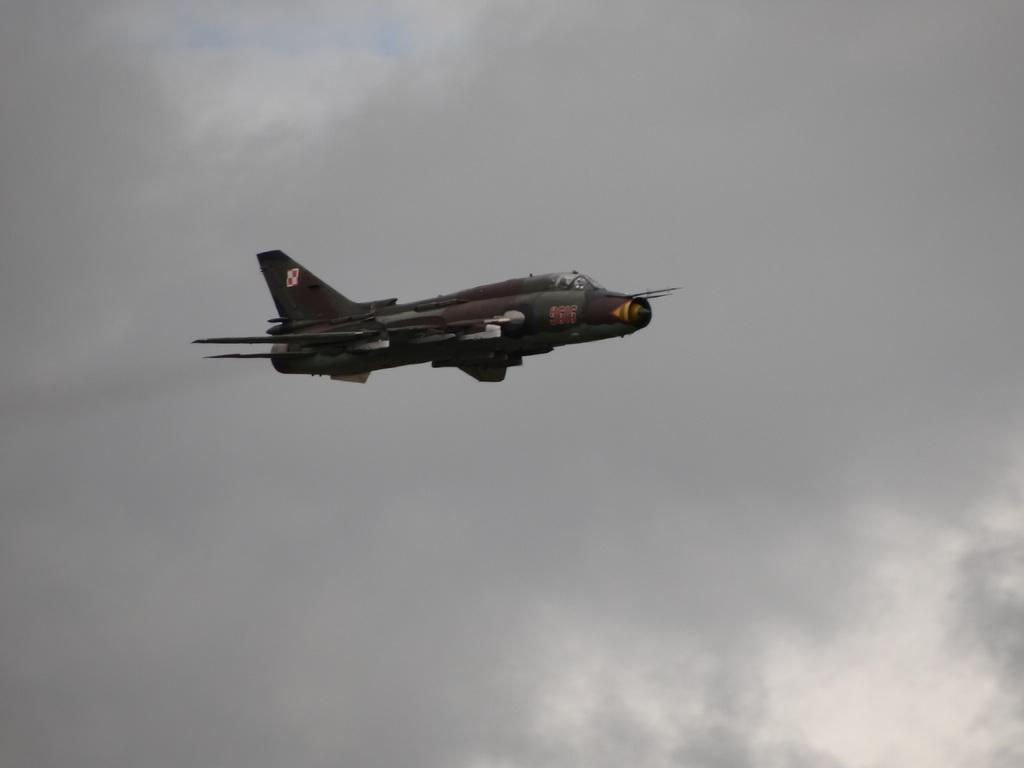What is the main subject of the image? There is an aircraft in the image. What is the aircraft doing in the image? The aircraft is flying in the air. What can be seen in the background of the image? The sky is visible in the background of the image. What type of jam is being spread on the company's logo in the image? There is no company or jam present in the image; it features an aircraft flying in the sky. 